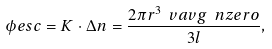Convert formula to latex. <formula><loc_0><loc_0><loc_500><loc_500>\phi e s c = K \cdot \Delta n = \frac { 2 \pi r ^ { 3 } \ v a v g \ n z e r o } { 3 l } ,</formula> 